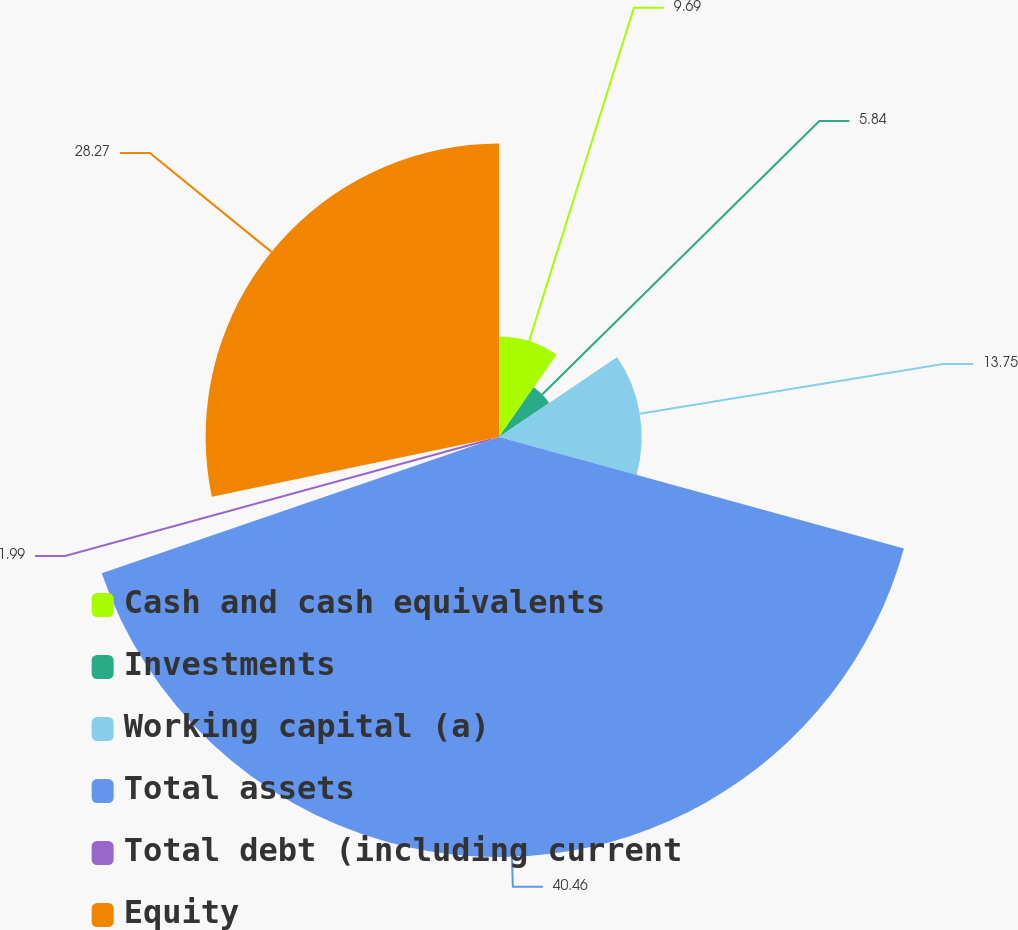Convert chart to OTSL. <chart><loc_0><loc_0><loc_500><loc_500><pie_chart><fcel>Cash and cash equivalents<fcel>Investments<fcel>Working capital (a)<fcel>Total assets<fcel>Total debt (including current<fcel>Equity<nl><fcel>9.69%<fcel>5.84%<fcel>13.75%<fcel>40.47%<fcel>1.99%<fcel>28.27%<nl></chart> 